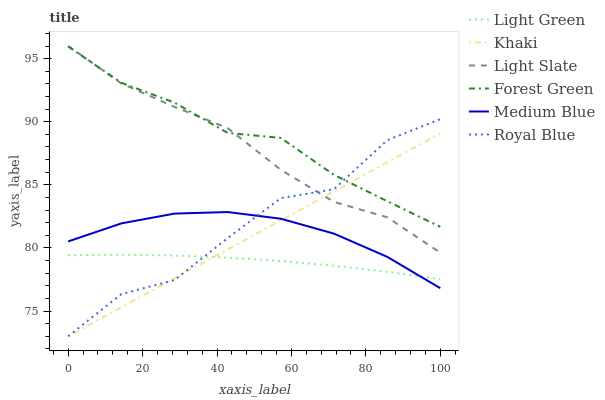Does Light Green have the minimum area under the curve?
Answer yes or no. Yes. Does Forest Green have the maximum area under the curve?
Answer yes or no. Yes. Does Light Slate have the minimum area under the curve?
Answer yes or no. No. Does Light Slate have the maximum area under the curve?
Answer yes or no. No. Is Khaki the smoothest?
Answer yes or no. Yes. Is Royal Blue the roughest?
Answer yes or no. Yes. Is Light Slate the smoothest?
Answer yes or no. No. Is Light Slate the roughest?
Answer yes or no. No. Does Khaki have the lowest value?
Answer yes or no. Yes. Does Light Slate have the lowest value?
Answer yes or no. No. Does Light Slate have the highest value?
Answer yes or no. Yes. Does Medium Blue have the highest value?
Answer yes or no. No. Is Light Green less than Forest Green?
Answer yes or no. Yes. Is Light Slate greater than Light Green?
Answer yes or no. Yes. Does Light Slate intersect Royal Blue?
Answer yes or no. Yes. Is Light Slate less than Royal Blue?
Answer yes or no. No. Is Light Slate greater than Royal Blue?
Answer yes or no. No. Does Light Green intersect Forest Green?
Answer yes or no. No. 